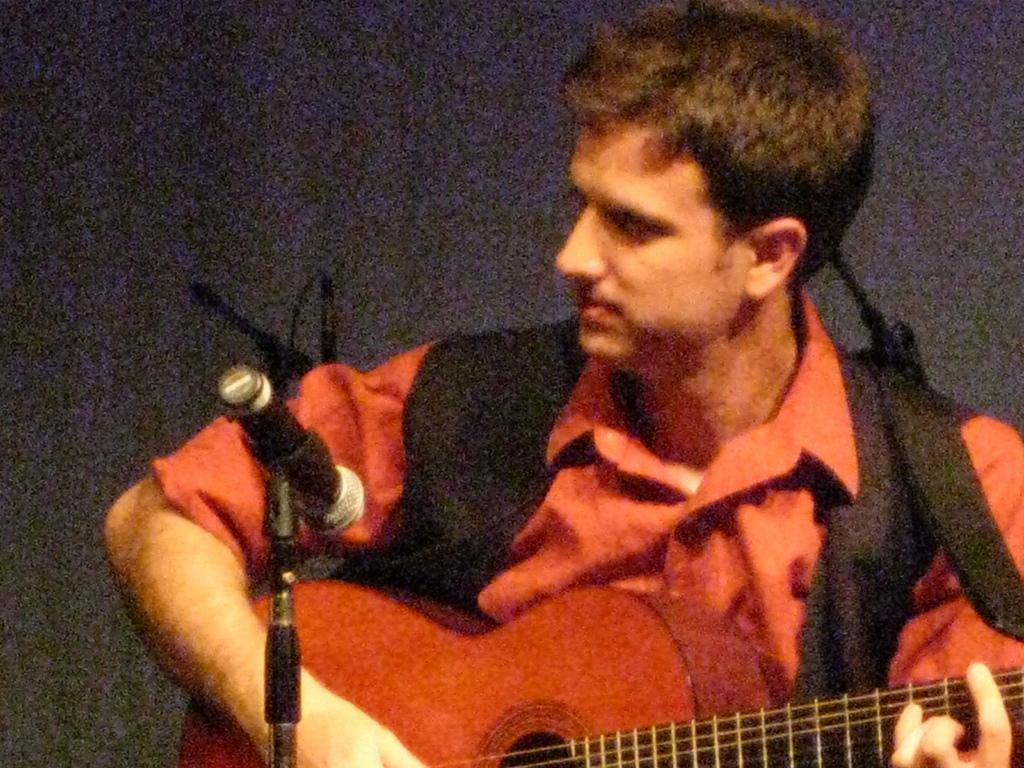What is the man in the image doing? The man is playing a guitar. What object is in front of the man? There is a microphone in front of the man. What can be seen in the background of the image? There is a wall in the background of the image. How does the man contribute to world peace in the image? The image does not show the man contributing to world peace; it only shows him playing a guitar and standing near a microphone. 